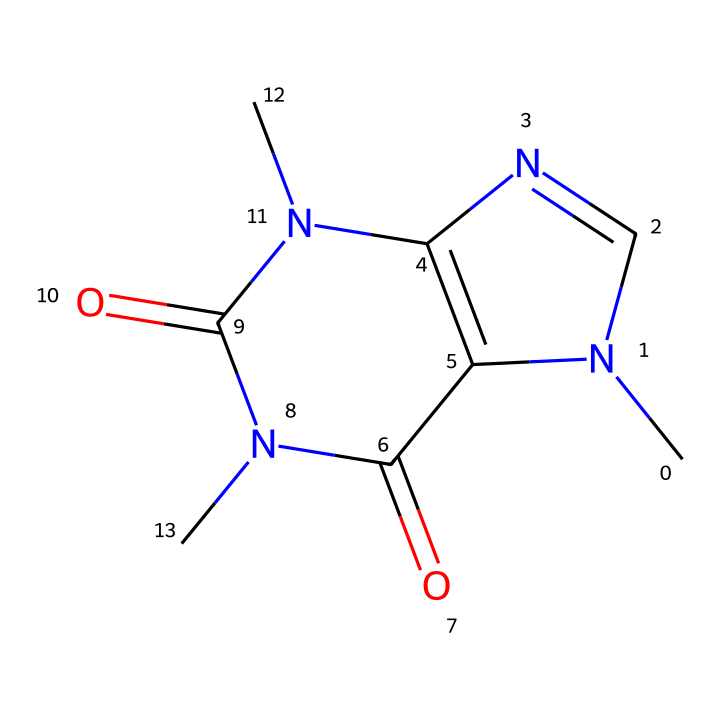What is the molecular formula of this compound? To determine the molecular formula, we count the atoms of each element represented in the SMILES string. The structure indicates there are 7 carbon atoms (C), 10 hydrogen atoms (H), 4 nitrogen atoms (N), and 2 oxygen atoms (O). Thus, the formula can be compiled as C7H10N4O2.
Answer: C7H10N4O2 How many nitrogen atoms are present in this molecule? In the SMILES representation, we can identify the nitrogen atoms shown in the structure. There are 4 instances of 'N' indicating the presence of 4 nitrogen atoms.
Answer: 4 Is this compound a stimulant? Given that the compound is caffeine, which is widely recognized for its stimulant effects, and that it is derived from the structure shown, we conclude that it acts as a stimulant when consumed in energy drinks.
Answer: yes How many rings are present in the molecular structure? The structure indicates that there are two fused rings formed by the connections of the carbon and nitrogen atoms. This can be identified by visualizing or interpreting the connections and layout of the SMILES representation.
Answer: 2 What functional groups are indicated in this molecule? By analyzing the SMILES representation, we can identify functional groups such as amides (due to the C(=O)N) and aromatic characters (due to the ring structure). The presence of carbonyl (C=O) and nitrogen groups contributes to its classification.
Answer: amide, aromatic Does this molecule have any chiral centers? In this compound's structure, there are no carbon atoms connected to four different substituents, which means there are no chiral centers present. The arrangement of atoms confirms this.
Answer: no 